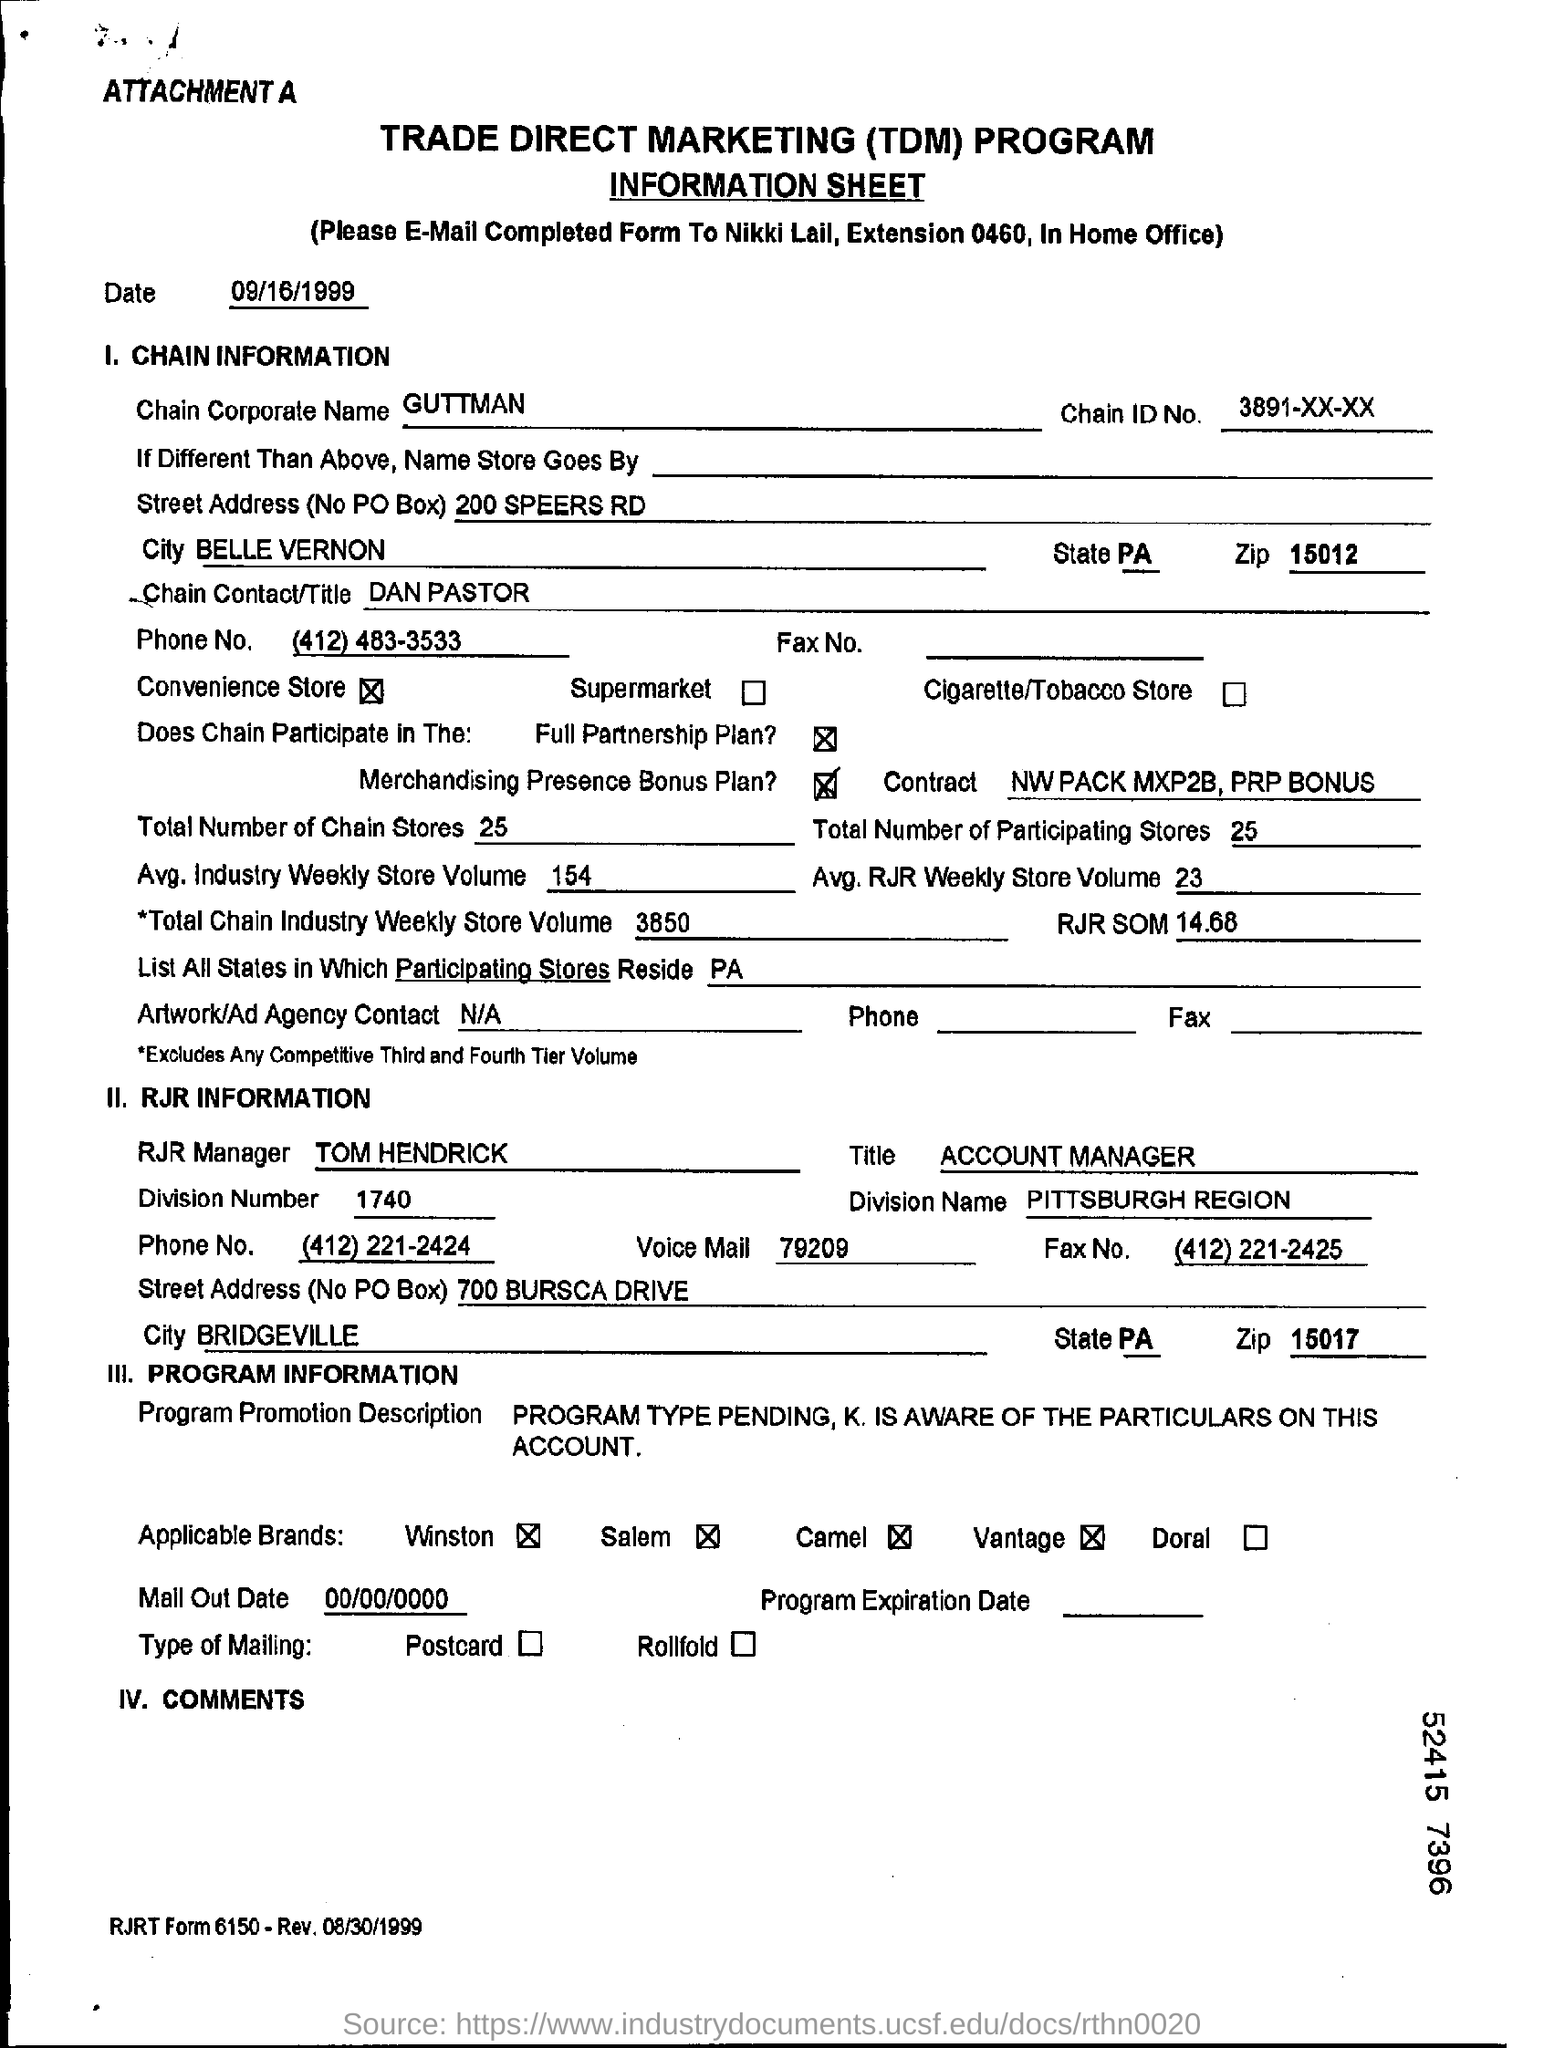Draw attention to some important aspects in this diagram. Trade Direct Marketing, commonly abbreviated as TDM, refers to a marketing strategy that involves directly selling products or services to consumers through various channels, such as retail stores, catalogs, and online platforms. It is recommended that the completed form be emailed to Nikki Lail. The chain ID number is 3891-XX-XX... This contract involves the specification of the Northwest pack, the MXP2B, and the PRP bonus. The person who is the Chain Contact/Title is Dan Pastor. 